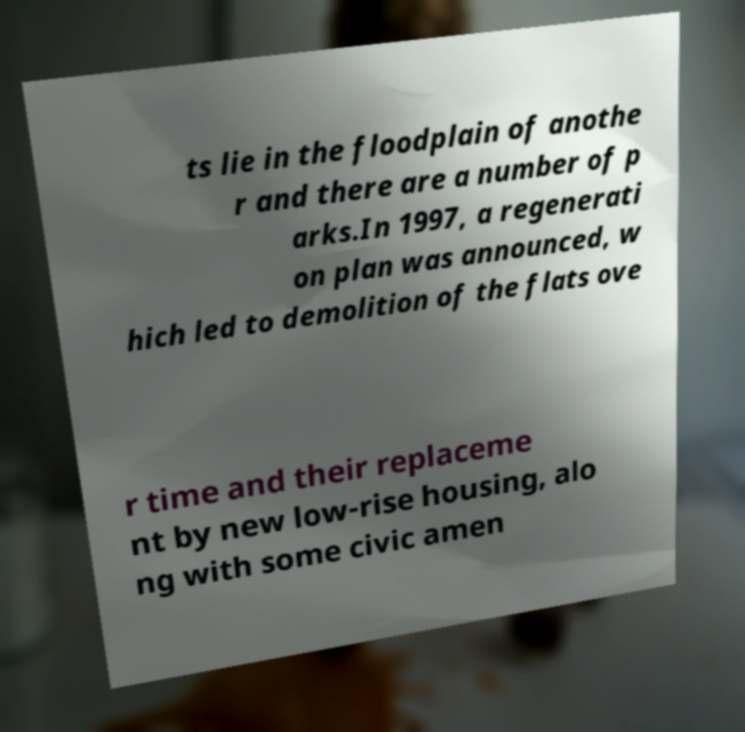For documentation purposes, I need the text within this image transcribed. Could you provide that? ts lie in the floodplain of anothe r and there are a number of p arks.In 1997, a regenerati on plan was announced, w hich led to demolition of the flats ove r time and their replaceme nt by new low-rise housing, alo ng with some civic amen 